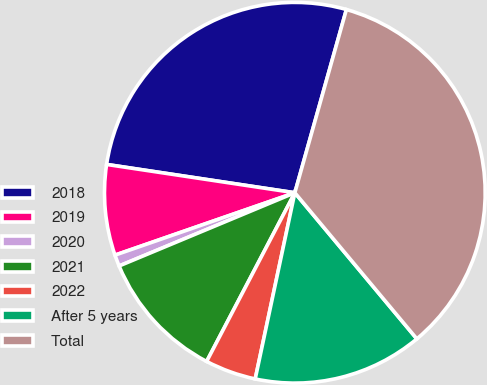<chart> <loc_0><loc_0><loc_500><loc_500><pie_chart><fcel>2018<fcel>2019<fcel>2020<fcel>2021<fcel>2022<fcel>After 5 years<fcel>Total<nl><fcel>26.99%<fcel>7.69%<fcel>0.97%<fcel>11.05%<fcel>4.33%<fcel>14.41%<fcel>34.56%<nl></chart> 